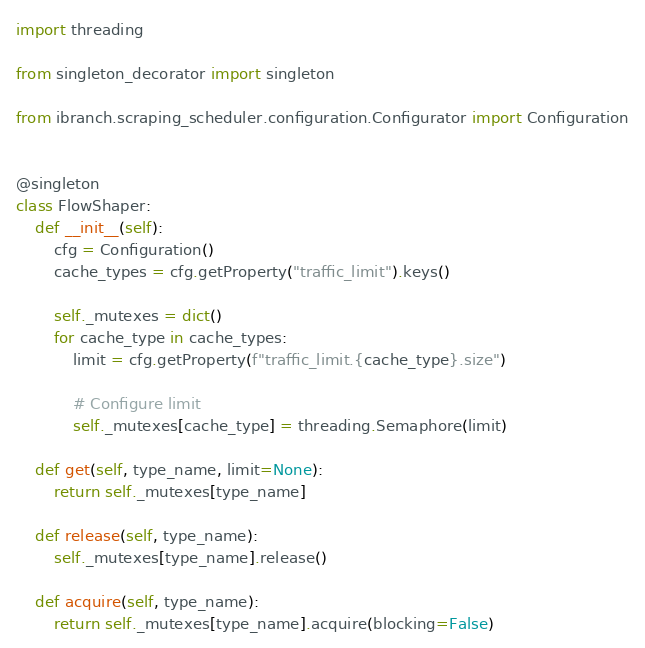Convert code to text. <code><loc_0><loc_0><loc_500><loc_500><_Python_>import threading

from singleton_decorator import singleton

from ibranch.scraping_scheduler.configuration.Configurator import Configuration


@singleton
class FlowShaper:
    def __init__(self):
        cfg = Configuration()
        cache_types = cfg.getProperty("traffic_limit").keys()

        self._mutexes = dict()
        for cache_type in cache_types:
            limit = cfg.getProperty(f"traffic_limit.{cache_type}.size")

            # Configure limit
            self._mutexes[cache_type] = threading.Semaphore(limit)

    def get(self, type_name, limit=None):
        return self._mutexes[type_name]

    def release(self, type_name):
        self._mutexes[type_name].release()

    def acquire(self, type_name):
        return self._mutexes[type_name].acquire(blocking=False)
</code> 